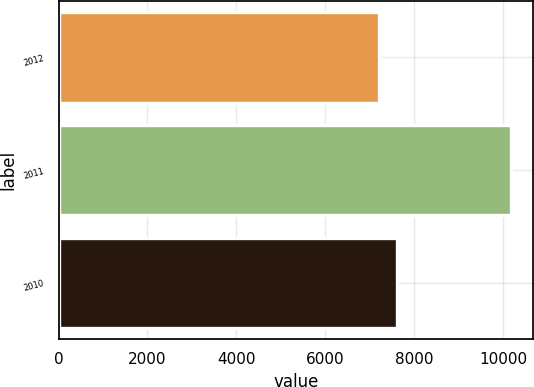Convert chart. <chart><loc_0><loc_0><loc_500><loc_500><bar_chart><fcel>2012<fcel>2011<fcel>2010<nl><fcel>7212<fcel>10175<fcel>7618<nl></chart> 